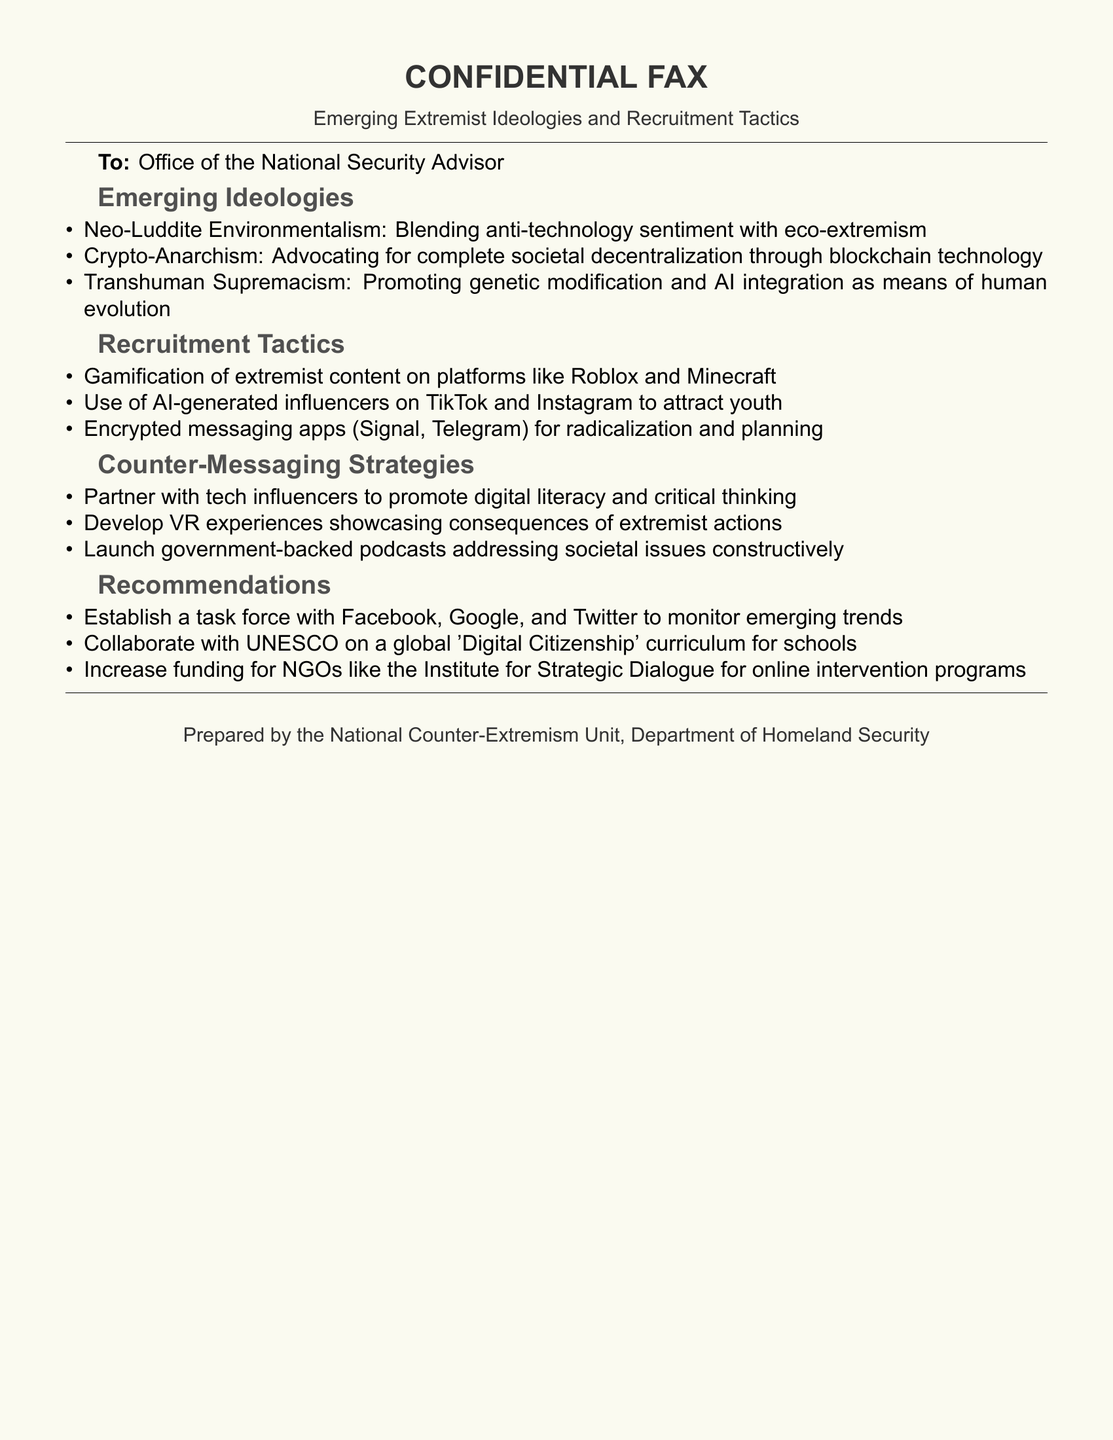What is the title of the document? The title is the main heading or label of the document, which is shown prominently.
Answer: Emerging Extremist Ideologies and Recruitment Tactics Who is the intended recipient of the fax? The recipient is mentioned at the beginning of the document, designated as the office or organization receiving the communication.
Answer: Office of the National Security Advisor What is one of the emerging extremist ideologies mentioned? To assess understanding of specific content, one can retrieve any example listed in the emerging ideologies section.
Answer: Neo-Luddite Environmentalism What platform is mentioned as a tool for gamification of extremist content? This question involves identifying specific technological platforms referenced in the recruitment tactics section.
Answer: Roblox What is one recommended counter-messaging strategy? This prompts for different strategies offered in the counter-messaging section, showcasing various approaches advised.
Answer: Partner with tech influencers How many emerging ideologies are listed in the document? This looks for a count of the items within the specified section of the document.
Answer: Three Which organization is suggested to collaborate with on a global curriculum? This question relates to specific organizations mentioned for partnerships in countering extremist ideologies.
Answer: UNESCO Which department prepared the document? This question identifies the agency responsible for creating the fax, reflecting document ownership.
Answer: Department of Homeland Security 